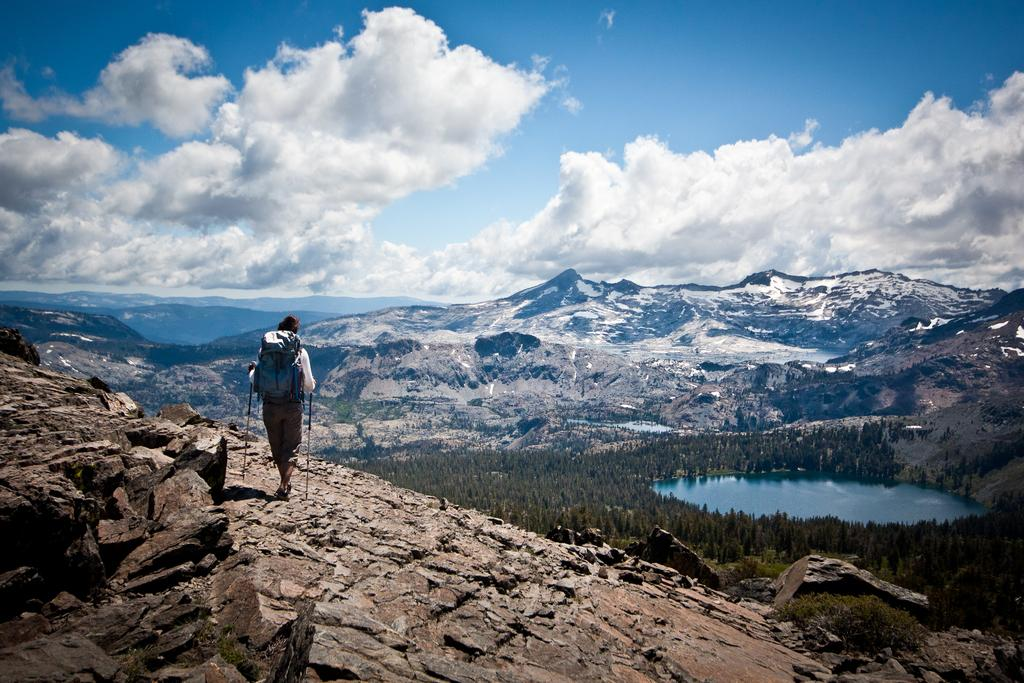What is the main subject of the image? There is a person in the image. What is the person wearing? The person is wearing a backpack. Where is the person located in the image? The person is walking on a hill. What can be seen on the ground in the image? There are rocks and plants in the image. What is visible in the background of the image? There are hills, trees, water, and a cloudy sky in the background of the image. What type of exchange is happening between the person and the trees in the image? There is no exchange happening between the person and the trees in the image. What kind of party is being held on the hill in the image? There is no party being held in the image; it is a person walking on a hill. 